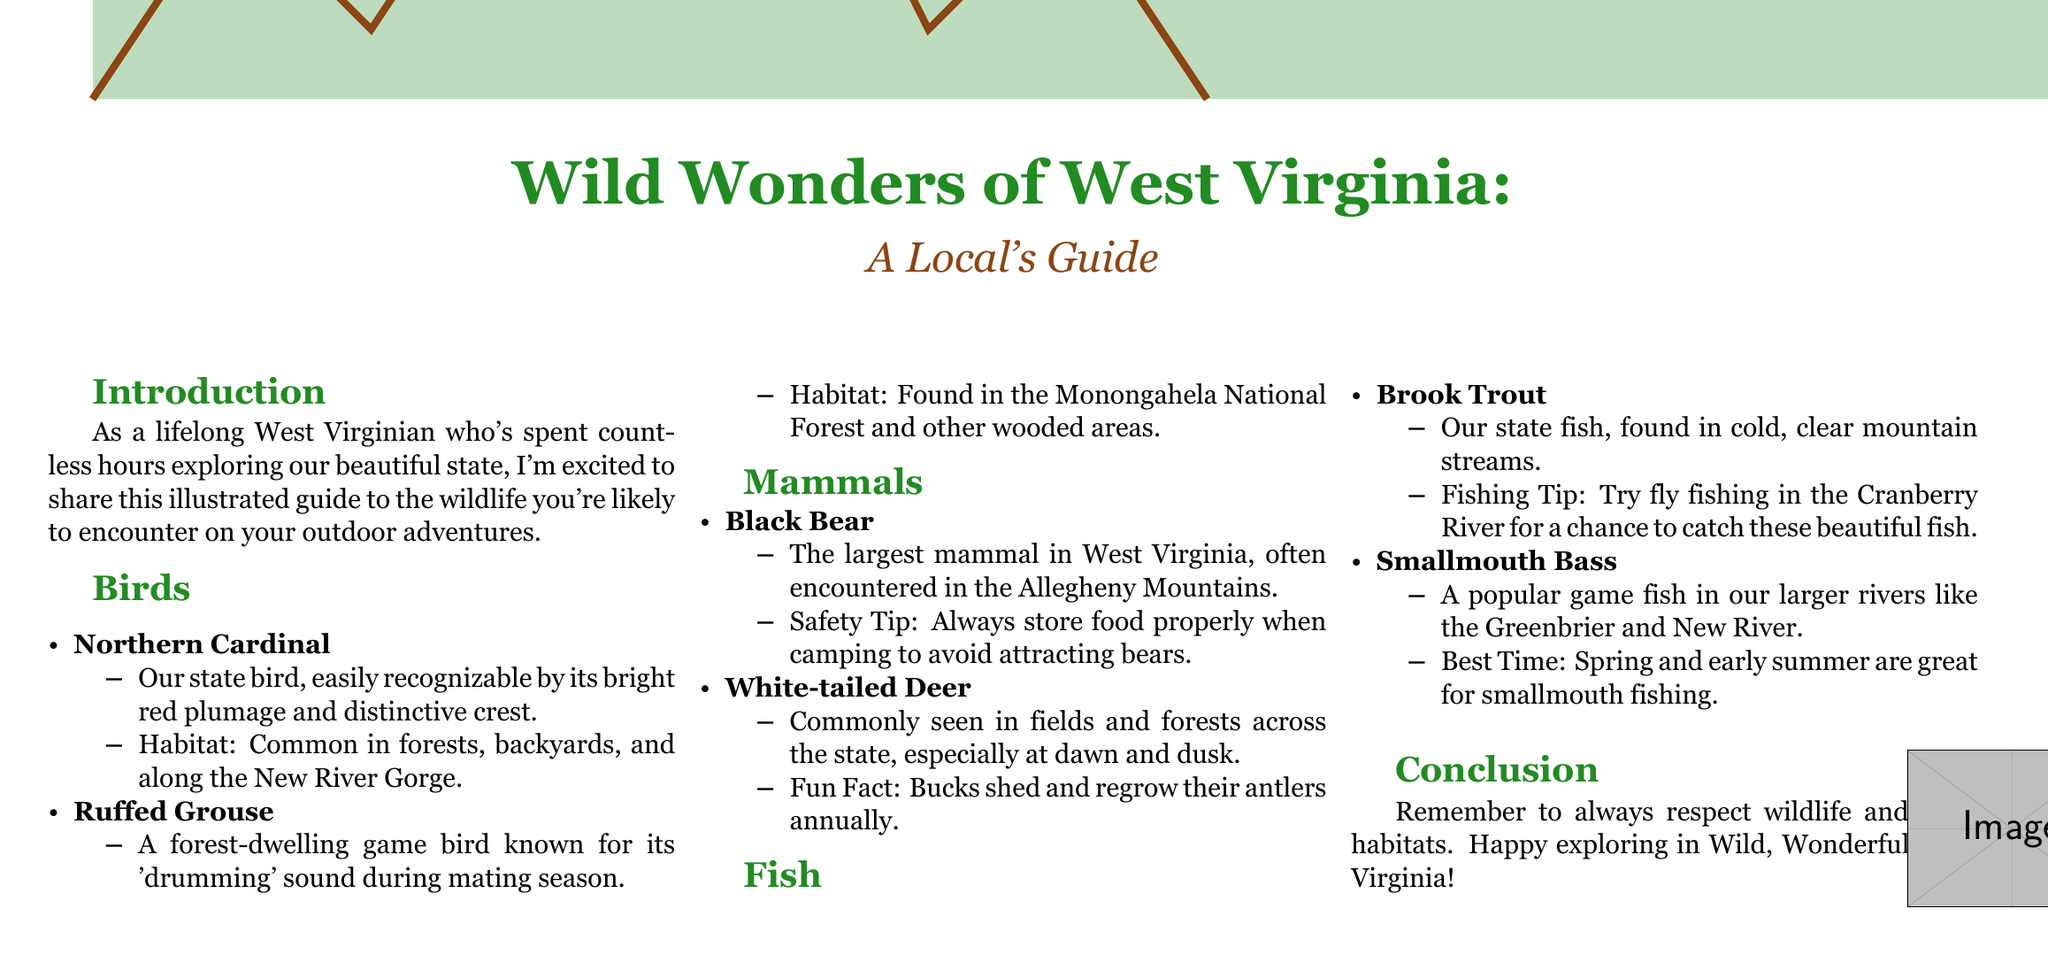What is the title of the guide? The title is found at the very top of the document and introduces the subject matter.
Answer: Wild Wonders of West Virginia Who is the author of the guide? The author is mentioned in the introduction as a lifelong West Virginian.
Answer: A lifelong West Virginian What is West Virginia's state bird? The document identifies the state bird in the section about birds.
Answer: Northern Cardinal Where can you find the Ruffed Grouse? The habitat of this bird is specified in the document.
Answer: Monongahela National Forest What is the largest mammal in West Virginia? The document provides information on the largest mammal under the mammals section.
Answer: Black Bear What is the state fish of West Virginia? The document lists the state fish in the fish section.
Answer: Brook Trout What time of year is best for fishing Smallmouth Bass? The document specifies a particular period in the fishing section.
Answer: Spring and early summer What is a safety tip when camping in bear country? The document offers advice in the context of the Black Bear entry.
Answer: Always store food properly How should wildlife be treated according to the conclusion? The conclusion summarizes guidelines for interacting with wildlife.
Answer: Respect wildlife and their habitats 